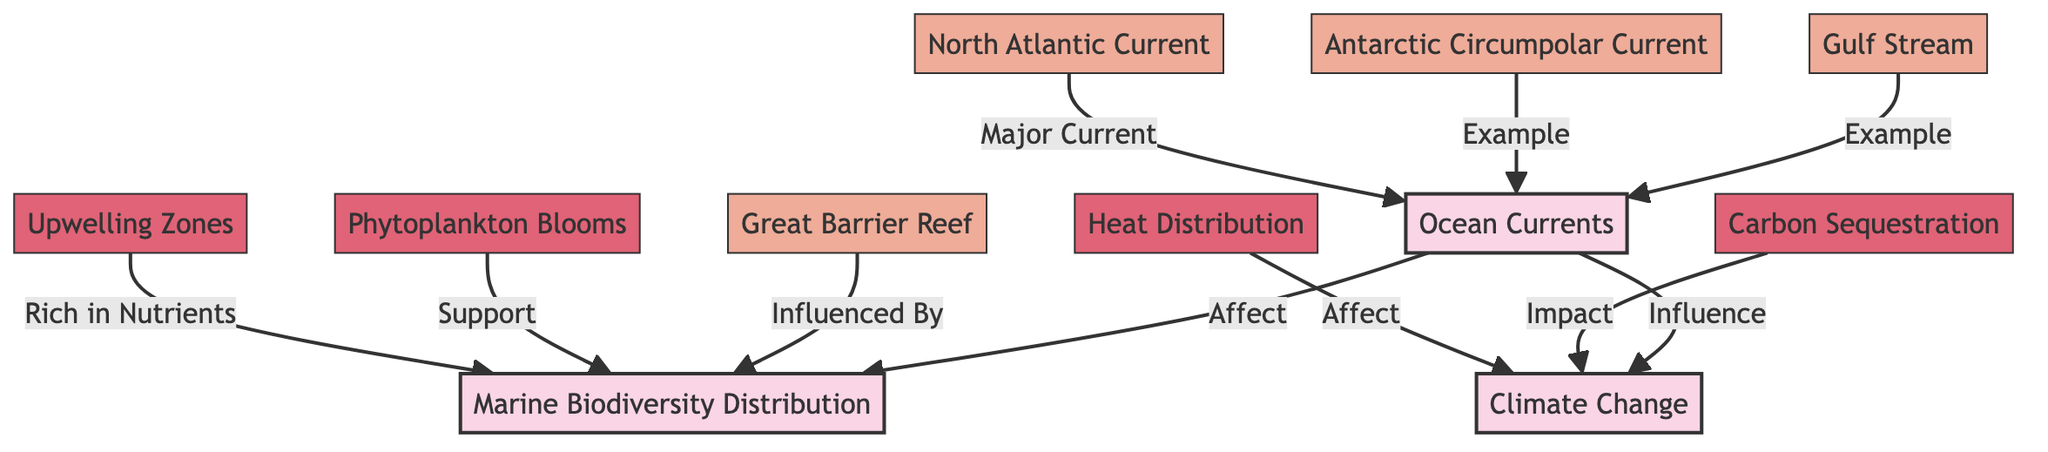What is the primary focus of the diagram? The primary focus of the diagram is to illustrate the relationship between ocean currents, marine biodiversity distribution, and climate change. This can be determined by identifying the main nodes at the top of the diagram.
Answer: Ocean Currents, Marine Biodiversity Distribution, Climate Change How many major ocean currents are represented in the diagram? The diagram contains two major ocean currents: the Gulf Stream and the Antarctic Circumpolar Current. By counting the nodes related to ocean currents, these two are found.
Answer: 2 What type of marine ecosystem is influenced by ocean currents, as shown in the diagram? The Great Barrier Reef is specifically mentioned in the context of being influenced by ocean currents, evidenced by its direct connection to the marine biodiversity distribution node.
Answer: Great Barrier Reef Which process supports marine biodiversity distribution according to the diagram? Phytoplankton blooms are indicated as a supporting process for marine biodiversity distribution. The connection from the small node "Phytoplankton Blooms" to "Marine Biodiversity Distribution" confirms this relationship.
Answer: Phytoplankton Blooms What effect do upwelling zones have on marine biodiversity distribution in the diagram? Upwelling zones are indicated as being rich in nutrients and thus support marine biodiversity distribution. The direct connection from the small node "Upwelling Zones" to "Marine Biodiversity Distribution" illustrates this.
Answer: Rich in Nutrients How does climate change relate to ocean currents based on the diagram? The diagram highlights that ocean currents influence climate change, as indicated by the directed edge from "Ocean Currents" to "Climate Change." This shows a direct relationship where changes in ocean currents can affect climatic conditions.
Answer: Influence What is one impact of ocean currents on climate change shown in the diagram? The diagram indicates that the heat distribution is one of the impacts of ocean currents on climate change, as evidenced by the connection from "Heat Distribution" to "Climate Change."
Answer: Heat Distribution In terms of marine biodiversity, what role does carbon sequestration play? The diagram shows that carbon sequestration impacts climate change, linking it indirectly to marine biodiversity distribution as it contributes to the overall health of marine ecosystems. The connection demonstrates this relationship.
Answer: Impact Identify a major current mentioned in the diagram. The North Atlantic Current is highlighted as a major current in the diagram, as indicated by its specific label in the subnode category.
Answer: North Atlantic Current 